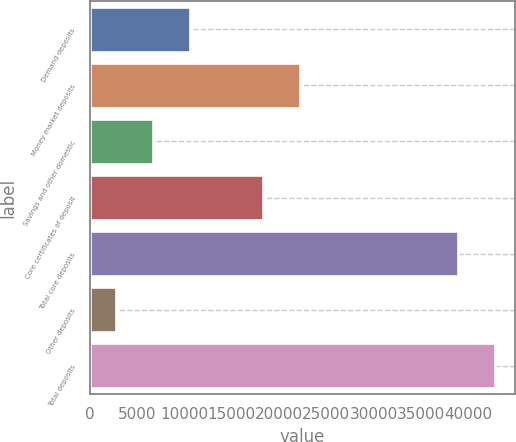<chart> <loc_0><loc_0><loc_500><loc_500><bar_chart><fcel>Demand deposits<fcel>Money market deposits<fcel>Savings and other domestic<fcel>Core certificates of deposit<fcel>Total core deposits<fcel>Other deposits<fcel>Total deposits<nl><fcel>10544.8<fcel>22229.5<fcel>6649.9<fcel>18334.6<fcel>38949<fcel>2755<fcel>42843.9<nl></chart> 